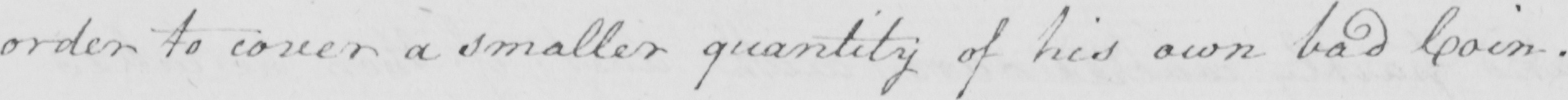Transcribe the text shown in this historical manuscript line. order to cover a smaller quantity of his own bad Coin . 